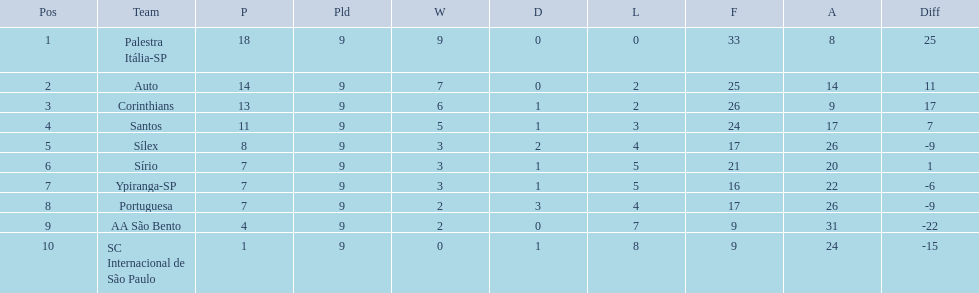What teams played in 1926? Palestra Itália-SP, Auto, Corinthians, Santos, Sílex, Sírio, Ypiranga-SP, Portuguesa, AA São Bento, SC Internacional de São Paulo. Did any team lose zero games? Palestra Itália-SP. 